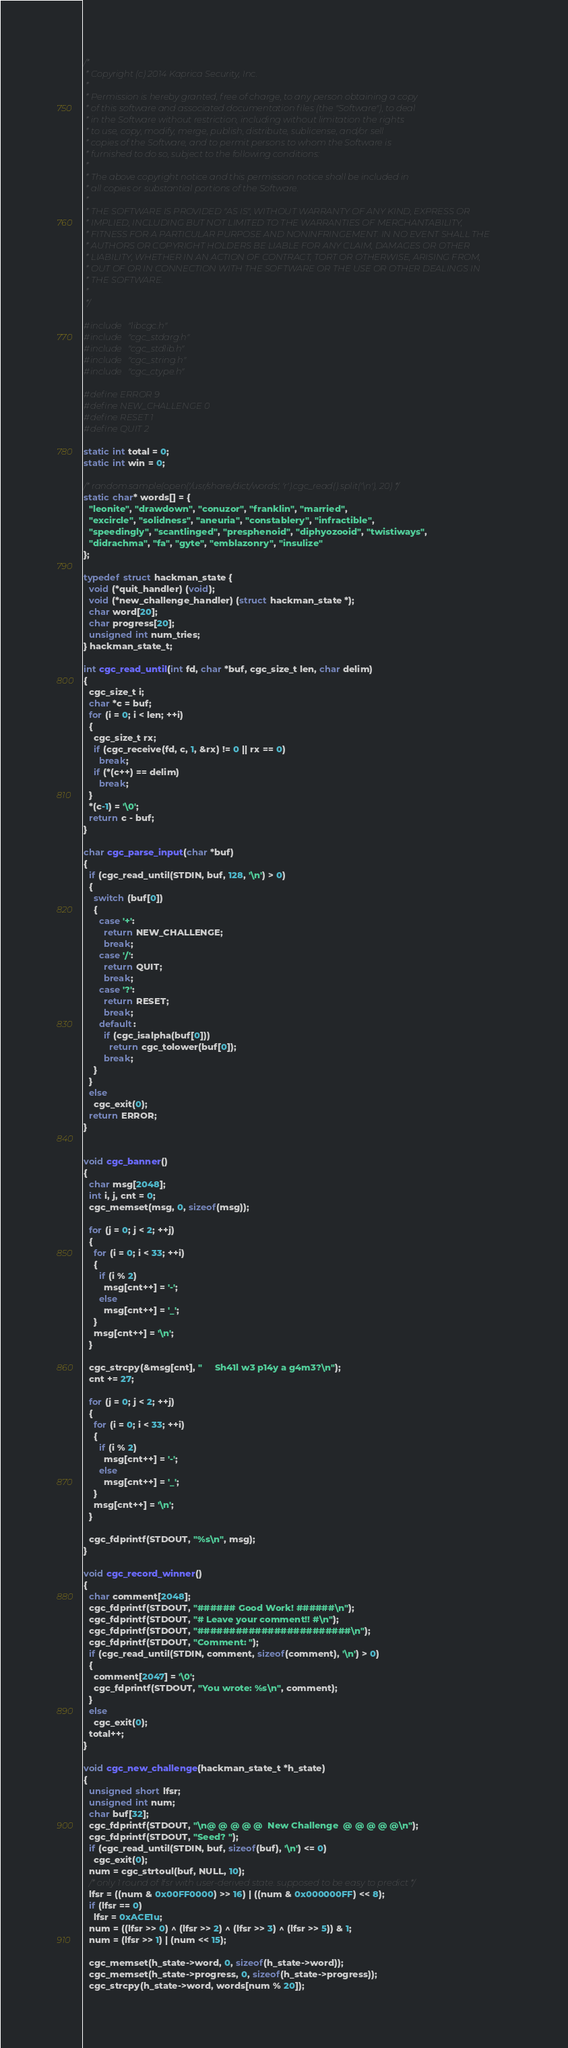<code> <loc_0><loc_0><loc_500><loc_500><_C_>/*
 * Copyright (c) 2014 Kaprica Security, Inc.
 *
 * Permission is hereby granted, free of charge, to any person obtaining a copy
 * of this software and associated documentation files (the "Software"), to deal
 * in the Software without restriction, including without limitation the rights
 * to use, copy, modify, merge, publish, distribute, sublicense, and/or sell
 * copies of the Software, and to permit persons to whom the Software is
 * furnished to do so, subject to the following conditions:
 *
 * The above copyright notice and this permission notice shall be included in
 * all copies or substantial portions of the Software.
 *
 * THE SOFTWARE IS PROVIDED "AS IS", WITHOUT WARRANTY OF ANY KIND, EXPRESS OR
 * IMPLIED, INCLUDING BUT NOT LIMITED TO THE WARRANTIES OF MERCHANTABILITY,
 * FITNESS FOR A PARTICULAR PURPOSE AND NONINFRINGEMENT. IN NO EVENT SHALL THE
 * AUTHORS OR COPYRIGHT HOLDERS BE LIABLE FOR ANY CLAIM, DAMAGES OR OTHER
 * LIABILITY, WHETHER IN AN ACTION OF CONTRACT, TORT OR OTHERWISE, ARISING FROM,
 * OUT OF OR IN CONNECTION WITH THE SOFTWARE OR THE USE OR OTHER DEALINGS IN
 * THE SOFTWARE.
 *
 */

#include "libcgc.h"
#include "cgc_stdarg.h"
#include "cgc_stdlib.h"
#include "cgc_string.h"
#include "cgc_ctype.h"

#define ERROR 9
#define NEW_CHALLENGE 0
#define RESET 1
#define QUIT 2

static int total = 0;
static int win = 0;

/* random.sample(open('/usr/share/dict/words', 'r').cgc_read().split('\n'), 20) */
static char* words[] = {
  "leonite", "drawdown", "conuzor", "franklin", "married",
  "excircle", "solidness", "aneuria", "constablery", "infractible",
  "speedingly", "scantlinged", "presphenoid", "diphyozooid", "twistiways",
  "didrachma", "fa", "gyte", "emblazonry", "insulize"
};

typedef struct hackman_state {
  void (*quit_handler) (void);
  void (*new_challenge_handler) (struct hackman_state *);
  char word[20];
  char progress[20];
  unsigned int num_tries;
} hackman_state_t;

int cgc_read_until(int fd, char *buf, cgc_size_t len, char delim)
{
  cgc_size_t i;
  char *c = buf;
  for (i = 0; i < len; ++i)
  {
    cgc_size_t rx;
    if (cgc_receive(fd, c, 1, &rx) != 0 || rx == 0)
      break;
    if (*(c++) == delim)
      break;
  }
  *(c-1) = '\0';
  return c - buf;
}

char cgc_parse_input(char *buf)
{
  if (cgc_read_until(STDIN, buf, 128, '\n') > 0)
  {
    switch (buf[0])
    {
      case '+':
        return NEW_CHALLENGE;
        break;
      case '/':
        return QUIT;
        break;
      case '?':
        return RESET;
        break;
      default:
        if (cgc_isalpha(buf[0]))
          return cgc_tolower(buf[0]);
        break;
    }
  }
  else
    cgc_exit(0);
  return ERROR;
}


void cgc_banner()
{
  char msg[2048];
  int i, j, cnt = 0;
  cgc_memset(msg, 0, sizeof(msg));

  for (j = 0; j < 2; ++j)
  {
    for (i = 0; i < 33; ++i)
    {
      if (i % 2)
        msg[cnt++] = '-';
      else
        msg[cnt++] = '_';
    }
    msg[cnt++] = '\n';
  }

  cgc_strcpy(&msg[cnt], "     Sh41l w3 p14y a g4m3?\n");
  cnt += 27;

  for (j = 0; j < 2; ++j)
  {
    for (i = 0; i < 33; ++i)
    {
      if (i % 2)
        msg[cnt++] = '-';
      else
        msg[cnt++] = '_';
    }
    msg[cnt++] = '\n';
  }

  cgc_fdprintf(STDOUT, "%s\n", msg);
}

void cgc_record_winner()
{
  char comment[2048];
  cgc_fdprintf(STDOUT, "###### Good Work! ######\n");
  cgc_fdprintf(STDOUT, "# Leave your comment!! #\n");
  cgc_fdprintf(STDOUT, "########################\n");
  cgc_fdprintf(STDOUT, "Comment: ");
  if (cgc_read_until(STDIN, comment, sizeof(comment), '\n') > 0)
  {
    comment[2047] = '\0';
    cgc_fdprintf(STDOUT, "You wrote: %s\n", comment);
  }
  else
    cgc_exit(0);
  total++;
}

void cgc_new_challenge(hackman_state_t *h_state)
{
  unsigned short lfsr;
  unsigned int num;
  char buf[32];
  cgc_fdprintf(STDOUT, "\n@ @ @ @ @  New Challenge  @ @ @ @ @\n");
  cgc_fdprintf(STDOUT, "Seed? ");
  if (cgc_read_until(STDIN, buf, sizeof(buf), '\n') <= 0)
    cgc_exit(0);
  num = cgc_strtoul(buf, NULL, 10);
  /* only 1 round of lfsr with user-derived state. supposed to be easy to predict */
  lfsr = ((num & 0x00FF0000) >> 16) | ((num & 0x000000FF) << 8);
  if (lfsr == 0)
    lfsr = 0xACE1u;
  num = ((lfsr >> 0) ^ (lfsr >> 2) ^ (lfsr >> 3) ^ (lfsr >> 5)) & 1;
  num = (lfsr >> 1) | (num << 15);

  cgc_memset(h_state->word, 0, sizeof(h_state->word));
  cgc_memset(h_state->progress, 0, sizeof(h_state->progress));
  cgc_strcpy(h_state->word, words[num % 20]);</code> 